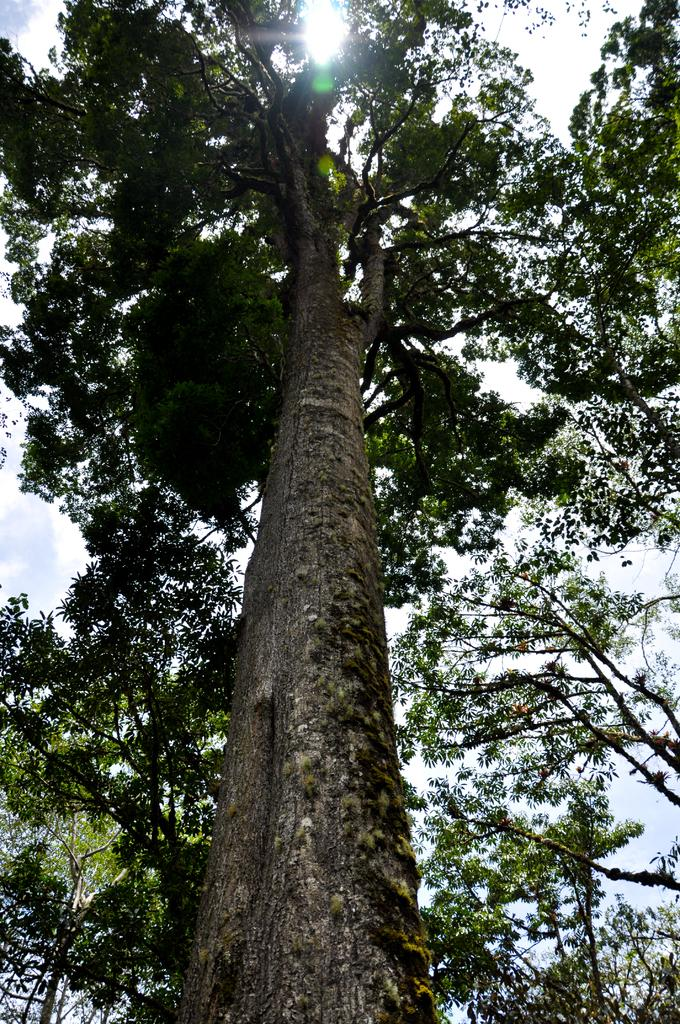What type of vegetation can be seen in the image? There are trees in the image. What part of the natural environment is visible in the image? The sky is visible in the background of the image. How many jelly containers are present in the image? There is no mention of jelly or containers in the image, so it is not possible to answer that question. 